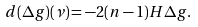Convert formula to latex. <formula><loc_0><loc_0><loc_500><loc_500>d ( \Delta g ) ( \nu ) = - 2 ( n - 1 ) H \Delta g .</formula> 